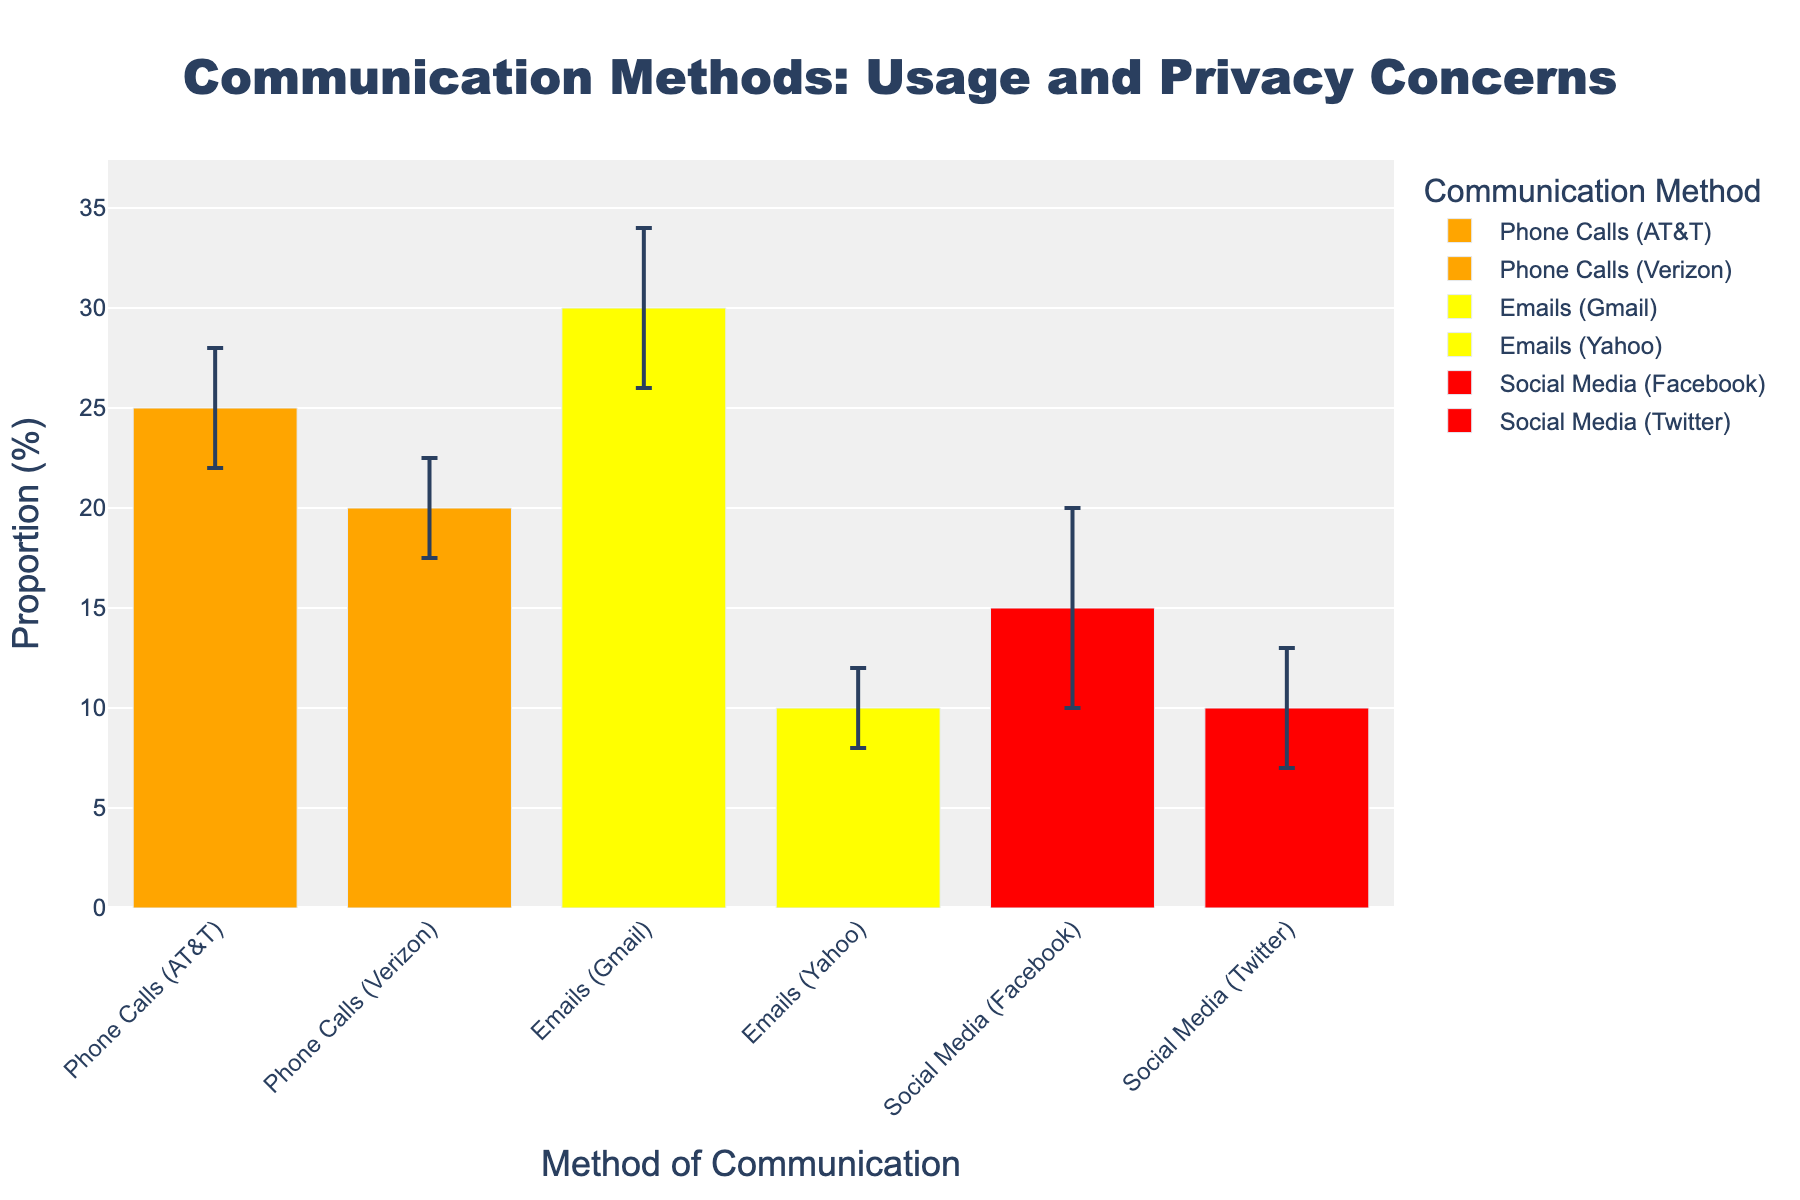What is the title of the plot? The title is usually located at the top of the plot. Reading it directly should give the answer.
Answer: Communication Methods: Usage and Privacy Concerns Which communication method has the highest proportion? By comparing the heights of the bars, we can see the bar representing 'Emails (Gmail)' is the highest at 30%.
Answer: Emails (Gmail) What is the difference in proportion between 'Phone Calls (AT&T)' and 'Social Media (Facebook)'? The proportion of 'Phone Calls (AT&T)' is 25% and 'Social Media (Facebook)' is 15%. Subtract 15 from 25 to find the difference.
Answer: 10% Which communication method is associated with the lowest privacy concern level? By looking at the colors and legend, 'Emails (Gmail)' and 'Emails (Yahoo)' are marked in yellow, indicating a medium privacy concern, which is the lowest among High, Medium, and Very High levels.
Answer: Emails (Gmail) / Emails (Yahoo) Which method of communication has the largest error margin? We look at the bars with error bars and see the length of these vertical lines. 'Social Media (Facebook)' has the error bar representing a value of 5, which is the longest.
Answer: Social Media (Facebook) What is the average proportion of all communication methods shown in the plot? Sum all proportions (25 + 20 + 30 + 10 + 15 + 10 = 110) and divide by the number of methods (6).
Answer: (25+20+30+10+15+10) / 6 = 18.33 How many communication methods are considered to have 'High' privacy concern levels? By looking at the colors and referencing the legend, 'Phone Calls (AT&T)' and 'Phone Calls (Verizon)' are marked in orange, indicating a 'High' privacy concern level. Count these methods.
Answer: 2 Which communication method has the smallest proportion, and what is it? By comparing the heights of the bars, it’s evident that 'Emails (Yahoo)' and 'Social Media (Twitter)' both are the smallest at 10%.
Answer: Emails (Yahoo) / Social Media (Twitter), 10% Which communication method has the most stable usage proportion (smallest error margin)? By observing the error bars, the shortest error bar corresponds to 'Phone Calls (Verizon)' with an error margin of 2.5.
Answer: Phone Calls (Verizon) What is the total range of proportions captured in this figure, from the lowest to the highest? The lowest value is 10% (for Emails (Yahoo) and Social Media (Twitter)) and the highest is 30% (for Emails (Gmail)). Subtract 10 from 30.
Answer: 20% 